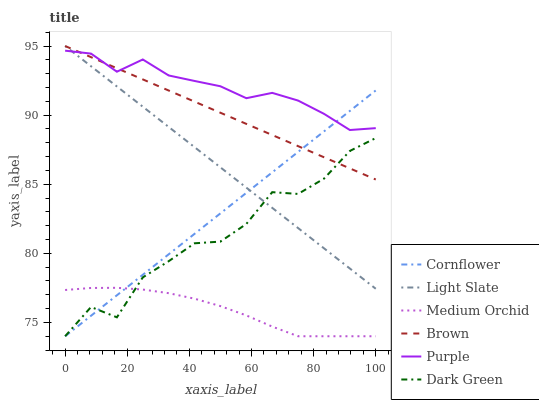Does Medium Orchid have the minimum area under the curve?
Answer yes or no. Yes. Does Purple have the maximum area under the curve?
Answer yes or no. Yes. Does Brown have the minimum area under the curve?
Answer yes or no. No. Does Brown have the maximum area under the curve?
Answer yes or no. No. Is Light Slate the smoothest?
Answer yes or no. Yes. Is Dark Green the roughest?
Answer yes or no. Yes. Is Brown the smoothest?
Answer yes or no. No. Is Brown the roughest?
Answer yes or no. No. Does Cornflower have the lowest value?
Answer yes or no. Yes. Does Brown have the lowest value?
Answer yes or no. No. Does Light Slate have the highest value?
Answer yes or no. Yes. Does Medium Orchid have the highest value?
Answer yes or no. No. Is Dark Green less than Purple?
Answer yes or no. Yes. Is Purple greater than Medium Orchid?
Answer yes or no. Yes. Does Purple intersect Light Slate?
Answer yes or no. Yes. Is Purple less than Light Slate?
Answer yes or no. No. Is Purple greater than Light Slate?
Answer yes or no. No. Does Dark Green intersect Purple?
Answer yes or no. No. 